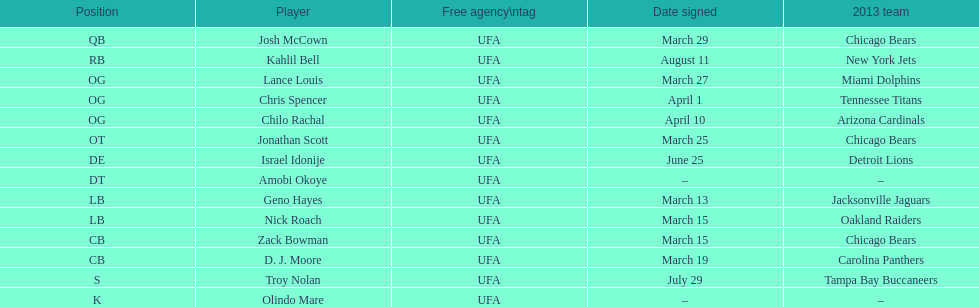In which position did both geno hayes and nick roach participate? LB. Would you mind parsing the complete table? {'header': ['Position', 'Player', 'Free agency\\ntag', 'Date signed', '2013 team'], 'rows': [['QB', 'Josh McCown', 'UFA', 'March 29', 'Chicago Bears'], ['RB', 'Kahlil Bell', 'UFA', 'August 11', 'New York Jets'], ['OG', 'Lance Louis', 'UFA', 'March 27', 'Miami Dolphins'], ['OG', 'Chris Spencer', 'UFA', 'April 1', 'Tennessee Titans'], ['OG', 'Chilo Rachal', 'UFA', 'April 10', 'Arizona Cardinals'], ['OT', 'Jonathan Scott', 'UFA', 'March 25', 'Chicago Bears'], ['DE', 'Israel Idonije', 'UFA', 'June 25', 'Detroit Lions'], ['DT', 'Amobi Okoye', 'UFA', '–', '–'], ['LB', 'Geno Hayes', 'UFA', 'March 13', 'Jacksonville Jaguars'], ['LB', 'Nick Roach', 'UFA', 'March 15', 'Oakland Raiders'], ['CB', 'Zack Bowman', 'UFA', 'March 15', 'Chicago Bears'], ['CB', 'D. J. Moore', 'UFA', 'March 19', 'Carolina Panthers'], ['S', 'Troy Nolan', 'UFA', 'July 29', 'Tampa Bay Buccaneers'], ['K', 'Olindo Mare', 'UFA', '–', '–']]} 